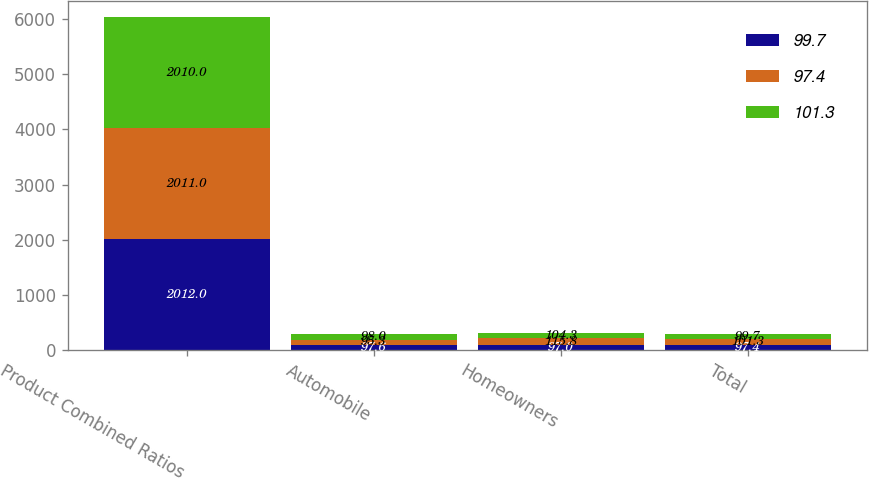Convert chart. <chart><loc_0><loc_0><loc_500><loc_500><stacked_bar_chart><ecel><fcel>Product Combined Ratios<fcel>Automobile<fcel>Homeowners<fcel>Total<nl><fcel>99.7<fcel>2012<fcel>97.6<fcel>97<fcel>97.4<nl><fcel>97.4<fcel>2011<fcel>95.3<fcel>115.8<fcel>101.3<nl><fcel>101.3<fcel>2010<fcel>98<fcel>104.3<fcel>99.7<nl></chart> 